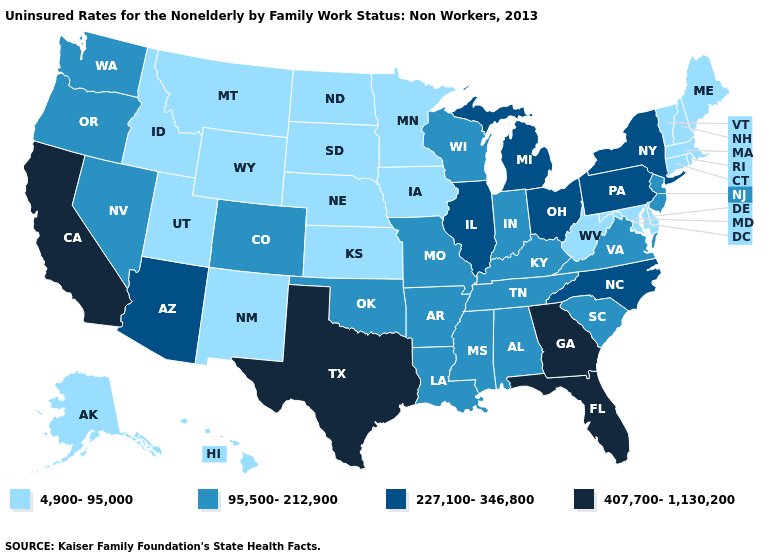Does Texas have a higher value than Iowa?
Quick response, please. Yes. Does Michigan have the highest value in the MidWest?
Concise answer only. Yes. How many symbols are there in the legend?
Give a very brief answer. 4. Name the states that have a value in the range 407,700-1,130,200?
Keep it brief. California, Florida, Georgia, Texas. Which states have the highest value in the USA?
Answer briefly. California, Florida, Georgia, Texas. Among the states that border Utah , does Arizona have the highest value?
Be succinct. Yes. How many symbols are there in the legend?
Quick response, please. 4. Which states hav the highest value in the MidWest?
Concise answer only. Illinois, Michigan, Ohio. Among the states that border Kansas , does Nebraska have the lowest value?
Short answer required. Yes. Does Alabama have the highest value in the USA?
Concise answer only. No. Which states have the lowest value in the USA?
Concise answer only. Alaska, Connecticut, Delaware, Hawaii, Idaho, Iowa, Kansas, Maine, Maryland, Massachusetts, Minnesota, Montana, Nebraska, New Hampshire, New Mexico, North Dakota, Rhode Island, South Dakota, Utah, Vermont, West Virginia, Wyoming. What is the value of West Virginia?
Write a very short answer. 4,900-95,000. Is the legend a continuous bar?
Quick response, please. No. Among the states that border Nebraska , which have the highest value?
Give a very brief answer. Colorado, Missouri. Name the states that have a value in the range 95,500-212,900?
Short answer required. Alabama, Arkansas, Colorado, Indiana, Kentucky, Louisiana, Mississippi, Missouri, Nevada, New Jersey, Oklahoma, Oregon, South Carolina, Tennessee, Virginia, Washington, Wisconsin. 